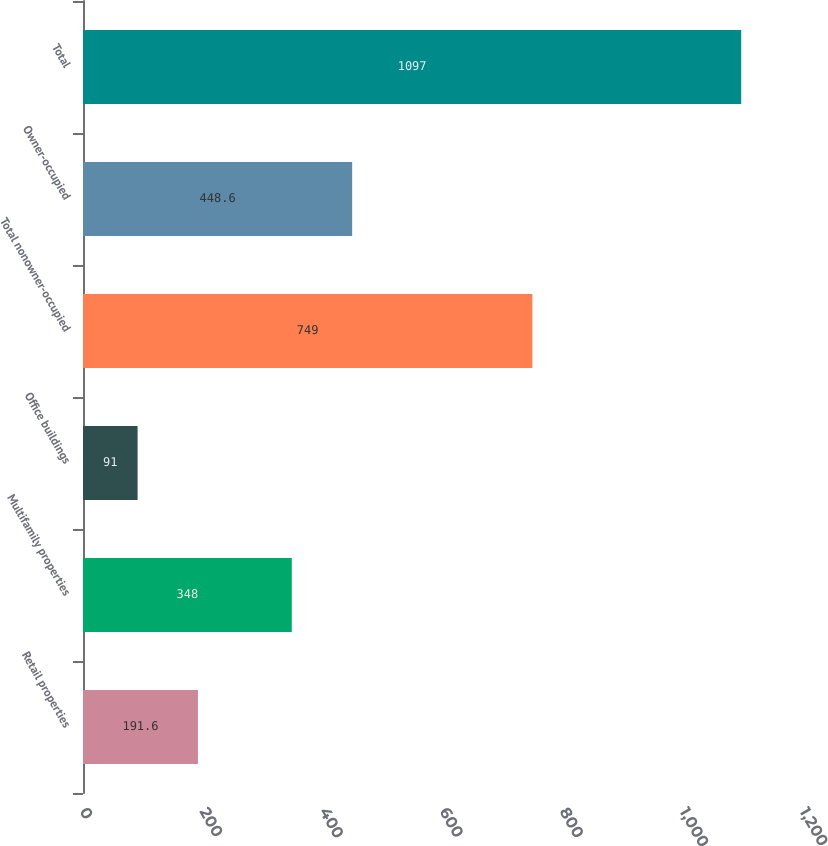Convert chart. <chart><loc_0><loc_0><loc_500><loc_500><bar_chart><fcel>Retail properties<fcel>Multifamily properties<fcel>Office buildings<fcel>Total nonowner-occupied<fcel>Owner-occupied<fcel>Total<nl><fcel>191.6<fcel>348<fcel>91<fcel>749<fcel>448.6<fcel>1097<nl></chart> 